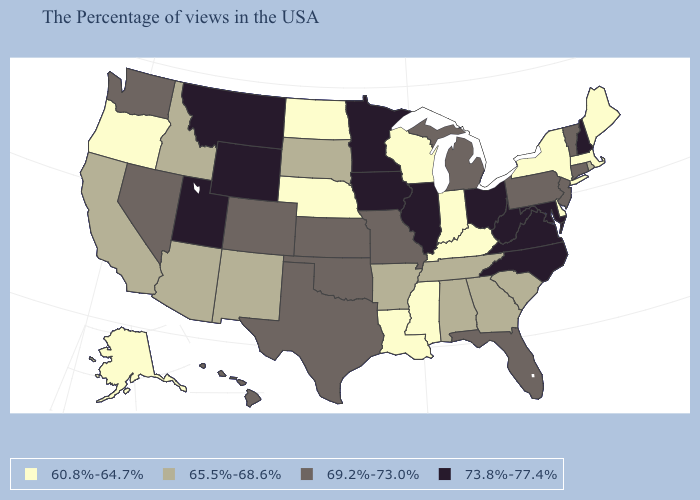Does New York have the lowest value in the Northeast?
Give a very brief answer. Yes. Does Virginia have the highest value in the South?
Concise answer only. Yes. What is the value of Wisconsin?
Give a very brief answer. 60.8%-64.7%. Among the states that border Maryland , does Delaware have the lowest value?
Quick response, please. Yes. What is the value of North Carolina?
Short answer required. 73.8%-77.4%. How many symbols are there in the legend?
Keep it brief. 4. Name the states that have a value in the range 65.5%-68.6%?
Concise answer only. Rhode Island, South Carolina, Georgia, Alabama, Tennessee, Arkansas, South Dakota, New Mexico, Arizona, Idaho, California. What is the value of Arizona?
Write a very short answer. 65.5%-68.6%. Does Missouri have the highest value in the MidWest?
Answer briefly. No. Does California have a higher value than Delaware?
Quick response, please. Yes. Name the states that have a value in the range 60.8%-64.7%?
Give a very brief answer. Maine, Massachusetts, New York, Delaware, Kentucky, Indiana, Wisconsin, Mississippi, Louisiana, Nebraska, North Dakota, Oregon, Alaska. Name the states that have a value in the range 60.8%-64.7%?
Quick response, please. Maine, Massachusetts, New York, Delaware, Kentucky, Indiana, Wisconsin, Mississippi, Louisiana, Nebraska, North Dakota, Oregon, Alaska. What is the value of Michigan?
Concise answer only. 69.2%-73.0%. Does Connecticut have the lowest value in the USA?
Answer briefly. No. 